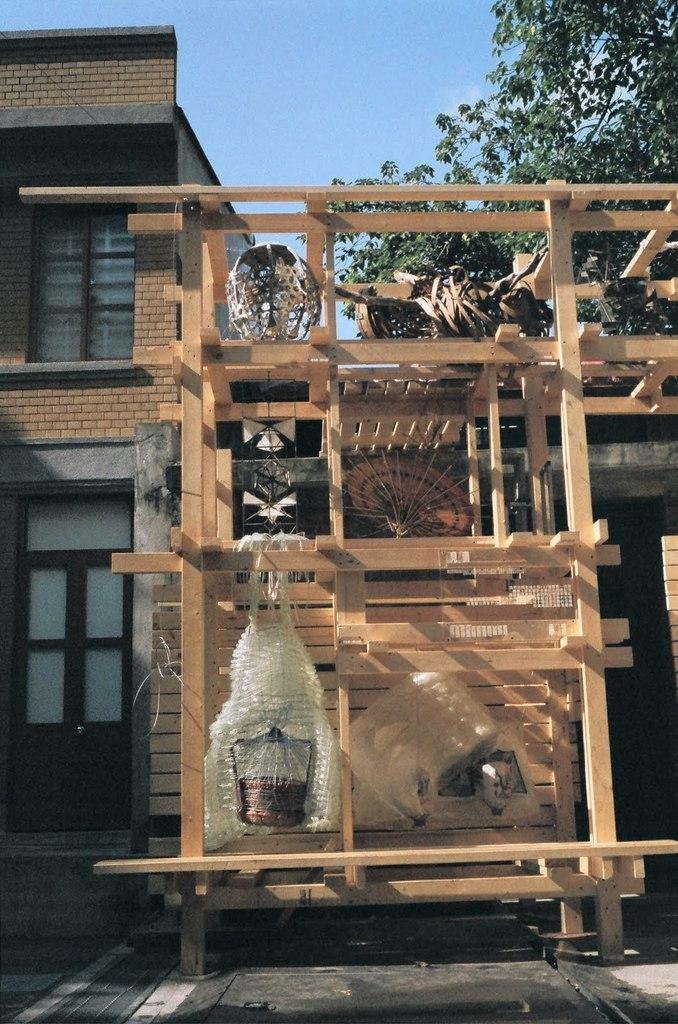Where was the image taken? The image was taken outside. What can be seen in the foreground of the image? There is a wooden object in the foreground of the image. What is visible in the background of the image? There is a sky, a tree, and a building visible in the background of the image. What type of bottle can be seen on the tree in the image? There is no bottle present on the tree in the image. 